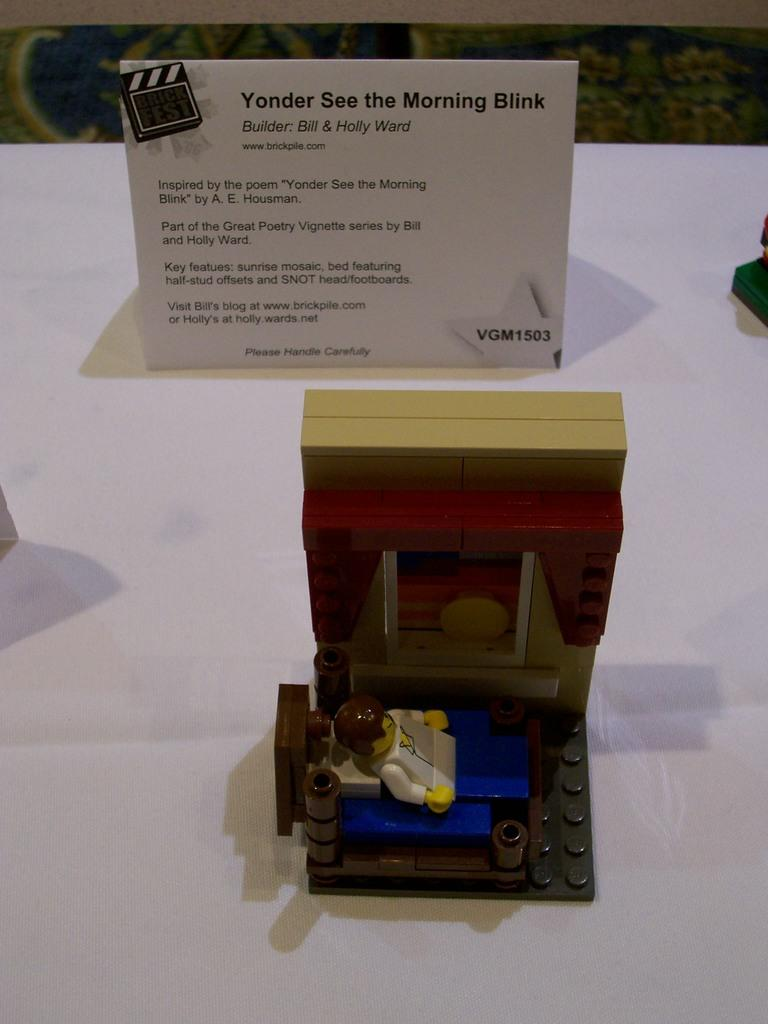<image>
Create a compact narrative representing the image presented. A building bricks creation built by Bill and Holly Ward. 